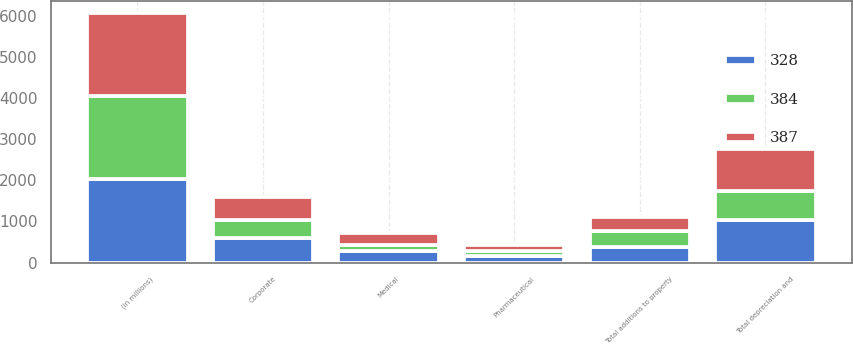Convert chart to OTSL. <chart><loc_0><loc_0><loc_500><loc_500><stacked_bar_chart><ecel><fcel>(in millions)<fcel>Pharmaceutical<fcel>Medical<fcel>Corporate<fcel>Total depreciation and<fcel>Total additions to property<nl><fcel>387<fcel>2019<fcel>147<fcel>288<fcel>565<fcel>1000<fcel>328<nl><fcel>328<fcel>2018<fcel>156<fcel>278<fcel>598<fcel>1032<fcel>384<nl><fcel>384<fcel>2017<fcel>122<fcel>156<fcel>439<fcel>717<fcel>387<nl></chart> 